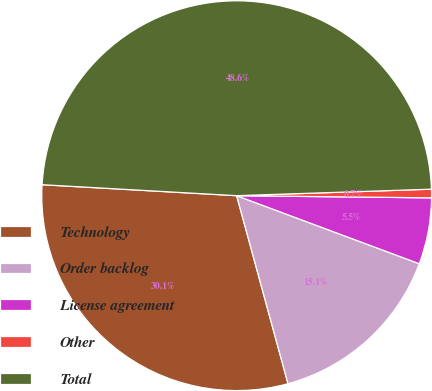<chart> <loc_0><loc_0><loc_500><loc_500><pie_chart><fcel>Technology<fcel>Order backlog<fcel>License agreement<fcel>Other<fcel>Total<nl><fcel>30.14%<fcel>15.08%<fcel>5.5%<fcel>0.71%<fcel>48.57%<nl></chart> 